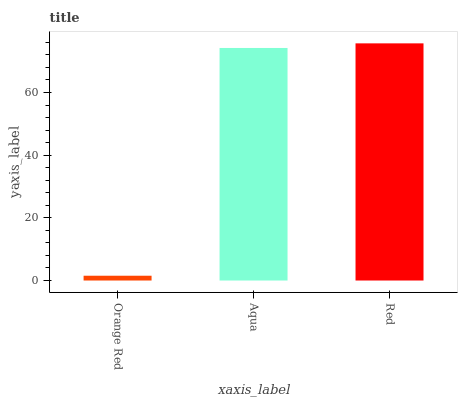Is Orange Red the minimum?
Answer yes or no. Yes. Is Red the maximum?
Answer yes or no. Yes. Is Aqua the minimum?
Answer yes or no. No. Is Aqua the maximum?
Answer yes or no. No. Is Aqua greater than Orange Red?
Answer yes or no. Yes. Is Orange Red less than Aqua?
Answer yes or no. Yes. Is Orange Red greater than Aqua?
Answer yes or no. No. Is Aqua less than Orange Red?
Answer yes or no. No. Is Aqua the high median?
Answer yes or no. Yes. Is Aqua the low median?
Answer yes or no. Yes. Is Red the high median?
Answer yes or no. No. Is Orange Red the low median?
Answer yes or no. No. 